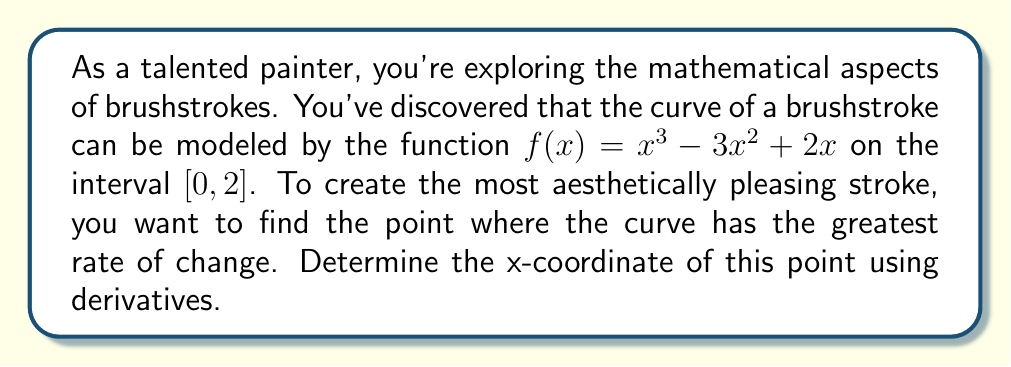What is the answer to this math problem? To find the point where the curve has the greatest rate of change, we need to follow these steps:

1) The rate of change of a function is given by its first derivative. So, we start by finding $f'(x)$:

   $f'(x) = 3x^2 - 6x + 2$

2) The point with the greatest rate of change will occur where the second derivative is zero. So, we need to find $f''(x)$:

   $f''(x) = 6x - 6$

3) Now, set $f''(x) = 0$ and solve for $x$:

   $6x - 6 = 0$
   $6x = 6$
   $x = 1$

4) To confirm this is a maximum rate of change (not a minimum), we can check the sign of $f''(x)$ on either side of $x = 1$:

   At $x = 0$: $f''(0) = -6$ (negative)
   At $x = 2$: $f''(2) = 6$ (positive)

   This sign change from negative to positive confirms that $x = 1$ is indeed a maximum.

5) Therefore, the point where the curve has the greatest rate of change occurs at $x = 1$.

[asy]
import graph;
size(200,200);

real f(real x) {return x^3 - 3x^2 + 2x;}
real fp(real x) {return 3x^2 - 6x + 2;}

draw(graph(f,0,2),blue);
draw(graph(fp,0,2),red);

dot((1,f(1)),blue);
dot((1,fp(1)),red);

xaxis("x",0,2,arrow=Arrow);
yaxis("y",-1,2,arrow=Arrow);

label("$f(x)$",(2,f(2)),E,blue);
label("$f'(x)$",(2,fp(2)),E,red);
label("(1, f(1))",(1,f(1)),NE,blue);
label("(1, f'(1))",(1,fp(1)),NE,red);
[/asy]
Answer: $x = 1$ 